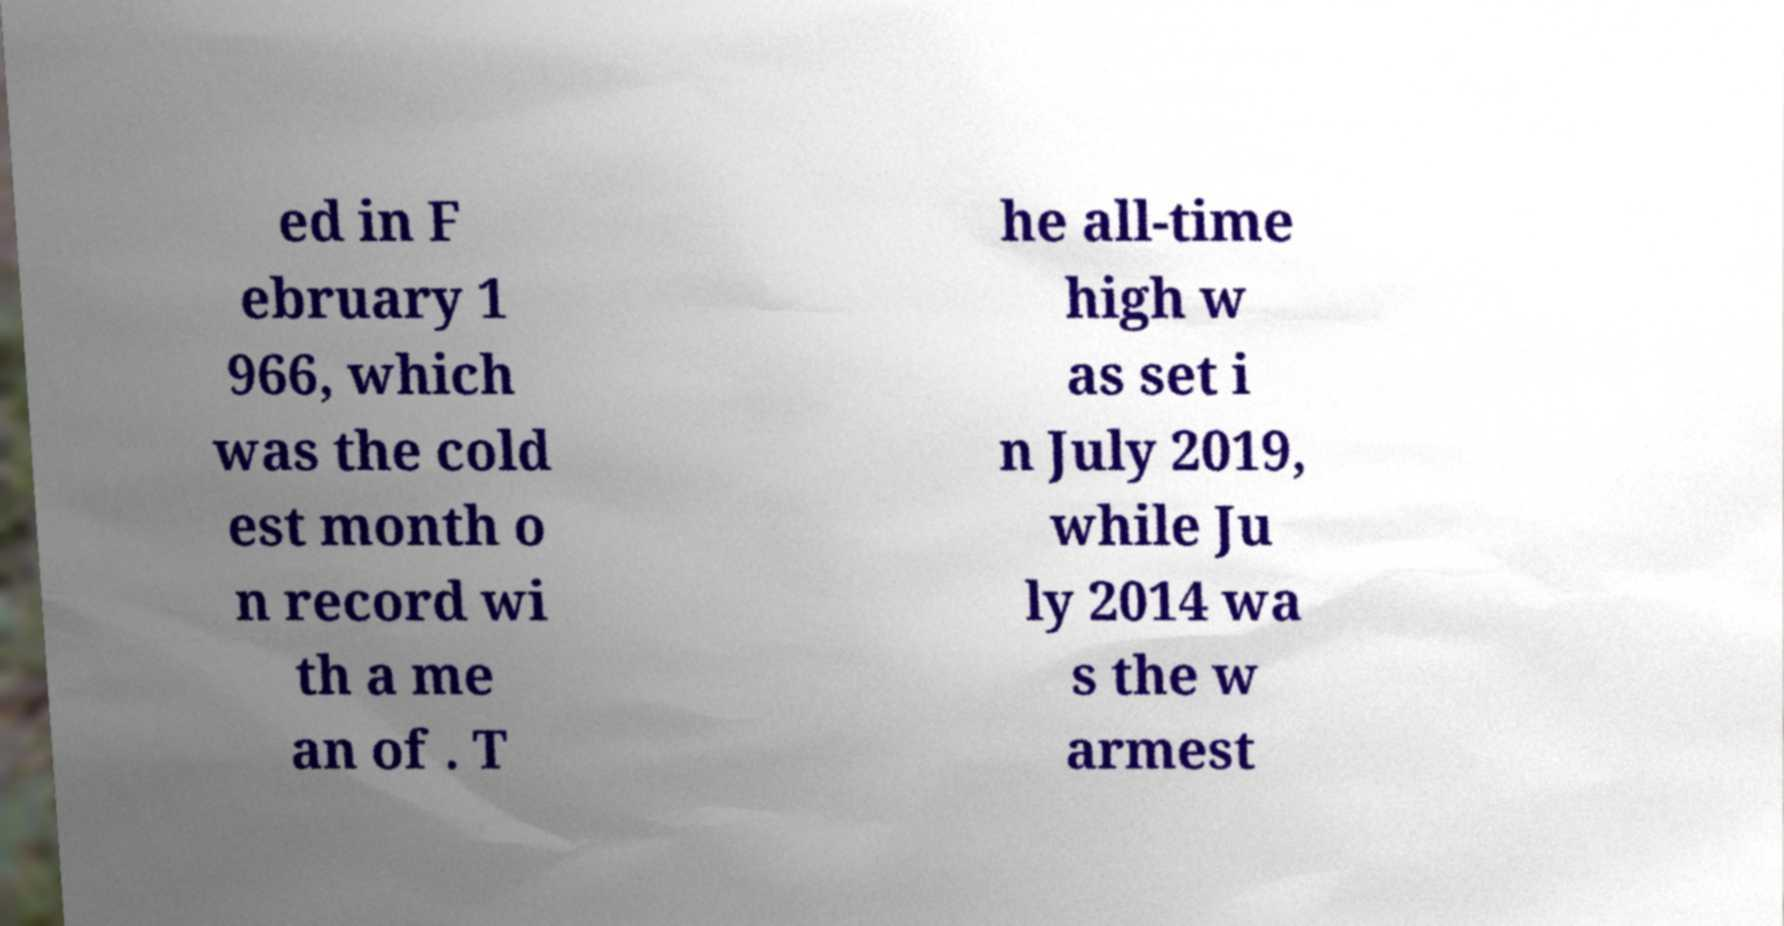Could you assist in decoding the text presented in this image and type it out clearly? ed in F ebruary 1 966, which was the cold est month o n record wi th a me an of . T he all-time high w as set i n July 2019, while Ju ly 2014 wa s the w armest 